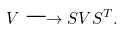Convert formula to latex. <formula><loc_0><loc_0><loc_500><loc_500>V \longrightarrow S V S ^ { T } .</formula> 